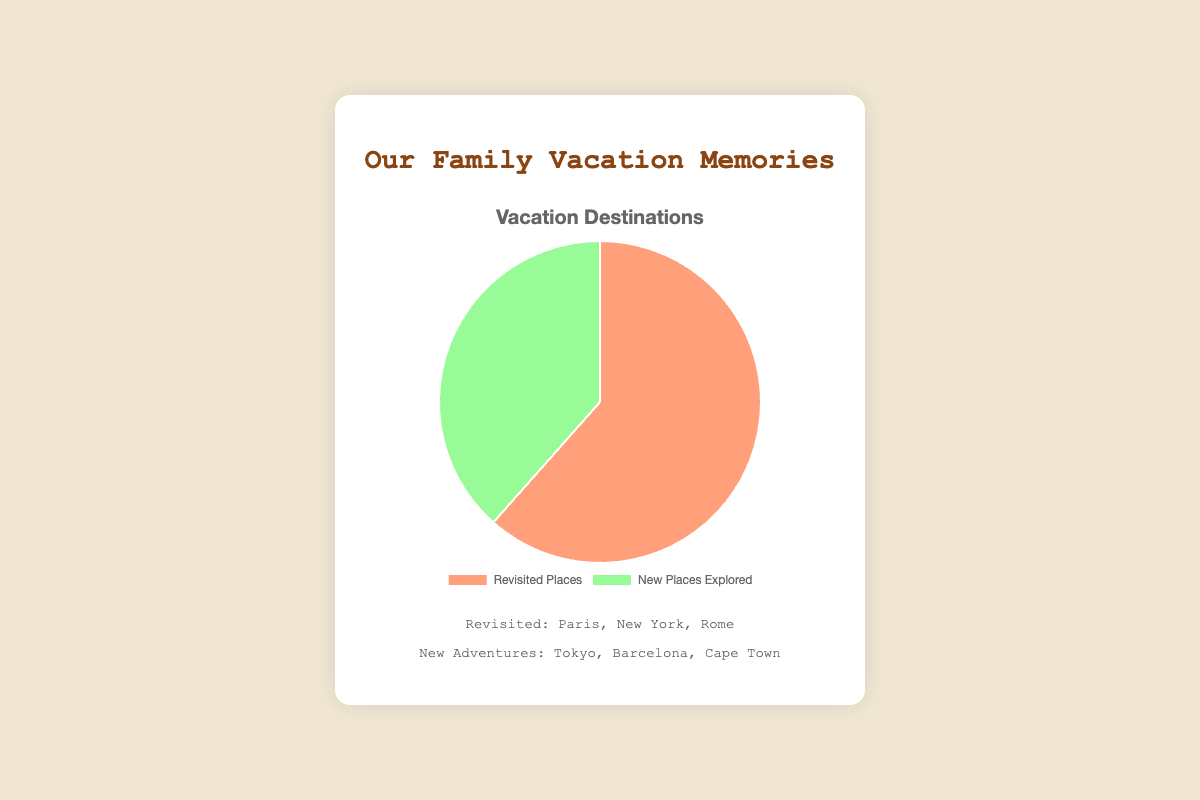Which type of vacation destination had more trips, revisited places or new places? There are 8 trips to revisited places and 5 to new places. 8 is greater than 5, so revisited places had more trips.
Answer: Revisited places What is the total number of trips taken altogether? Sum the trips to revisited places and new places: 8 (revisited) + 5 (new) = 13 trips.
Answer: 13 How many more trips were taken to revisited places compared to new places? Subtract the number of new trips from revisited trips: 8 (revisited) - 5 (new) = 3 more trips to revisited places.
Answer: 3 What percentage of the total trips were to new places? First, find the total number of trips: 8 (revisited) + 5 (new) = 13. Then divide the number of new trips by the total and multiply by 100 to get the percentage: (5/13) * 100 ≈ 38.46%.
Answer: 38.46% What color represents the new places on the pie chart? The new places section is marked in green, as indicated in the figure.
Answer: Green If two more trips were taken to new places, how would the distribution change? Adding 2 trips to new places means revisited places would remain 8 and new places would be 7. Recalculate the percentages: (8/15) * 100 ≈ 53.33% revisited, (7/15) * 100 ≈ 46.67% new.
Answer: 53.33% revisited, 46.67% new Is the "Revisited Places" section larger, smaller, or equal in size to the "New Places Explored" section on the pie chart? The "Revisited Places" section is larger because it represents 8 trips versus 5 for "New Places Explored".
Answer: Larger What do the colors represent on the pie chart? The pie chart uses salmon (light red) for revisited places and green for new places explored.
Answer: Revisited places: salmon, New places: green Which destinations do the family revisit most often? Examples provided indicate that the family revisited Paris, New York, and Rome the most.
Answer: Paris, New York, Rome Which new destinations has the family recently explored? Examples of places recently explored by the family are Tokyo, Barcelona, and Cape Town.
Answer: Tokyo, Barcelona, Cape Town 